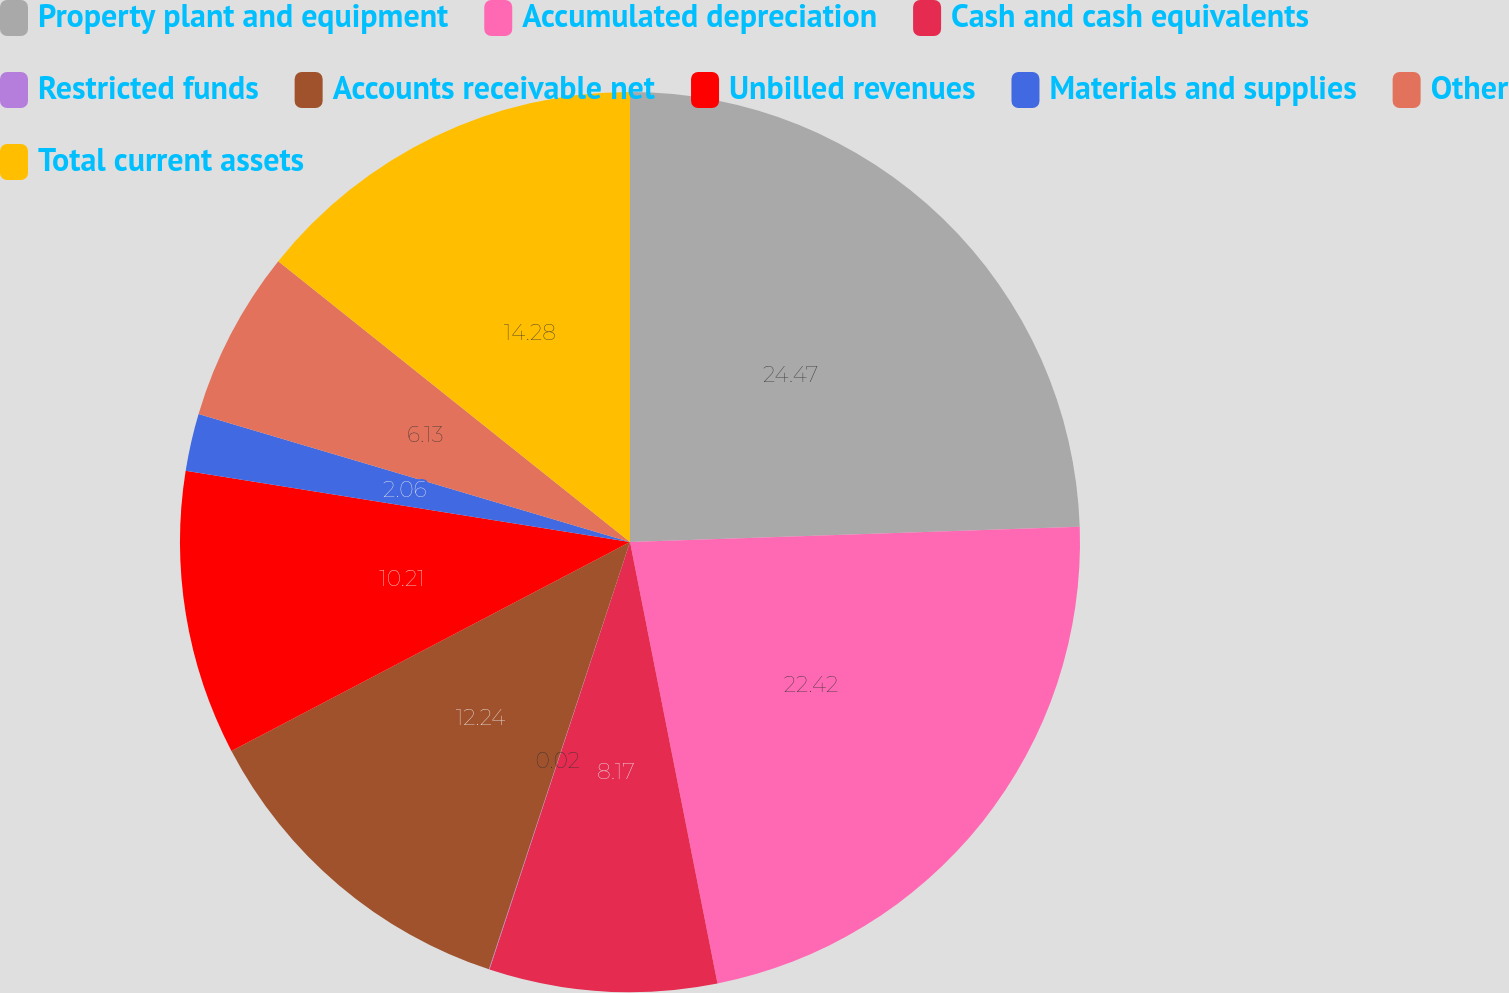Convert chart to OTSL. <chart><loc_0><loc_0><loc_500><loc_500><pie_chart><fcel>Property plant and equipment<fcel>Accumulated depreciation<fcel>Cash and cash equivalents<fcel>Restricted funds<fcel>Accounts receivable net<fcel>Unbilled revenues<fcel>Materials and supplies<fcel>Other<fcel>Total current assets<nl><fcel>24.46%<fcel>22.42%<fcel>8.17%<fcel>0.02%<fcel>12.24%<fcel>10.21%<fcel>2.06%<fcel>6.13%<fcel>14.28%<nl></chart> 